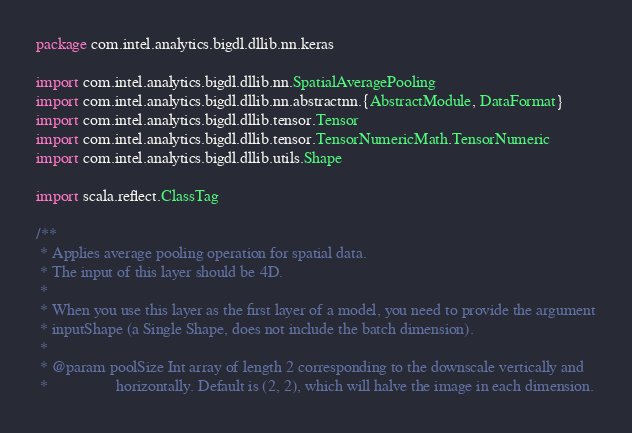<code> <loc_0><loc_0><loc_500><loc_500><_Scala_>
package com.intel.analytics.bigdl.dllib.nn.keras

import com.intel.analytics.bigdl.dllib.nn.SpatialAveragePooling
import com.intel.analytics.bigdl.dllib.nn.abstractnn.{AbstractModule, DataFormat}
import com.intel.analytics.bigdl.dllib.tensor.Tensor
import com.intel.analytics.bigdl.dllib.tensor.TensorNumericMath.TensorNumeric
import com.intel.analytics.bigdl.dllib.utils.Shape

import scala.reflect.ClassTag

/**
 * Applies average pooling operation for spatial data.
 * The input of this layer should be 4D.
 *
 * When you use this layer as the first layer of a model, you need to provide the argument
 * inputShape (a Single Shape, does not include the batch dimension).
 *
 * @param poolSize Int array of length 2 corresponding to the downscale vertically and
 *                 horizontally. Default is (2, 2), which will halve the image in each dimension.</code> 